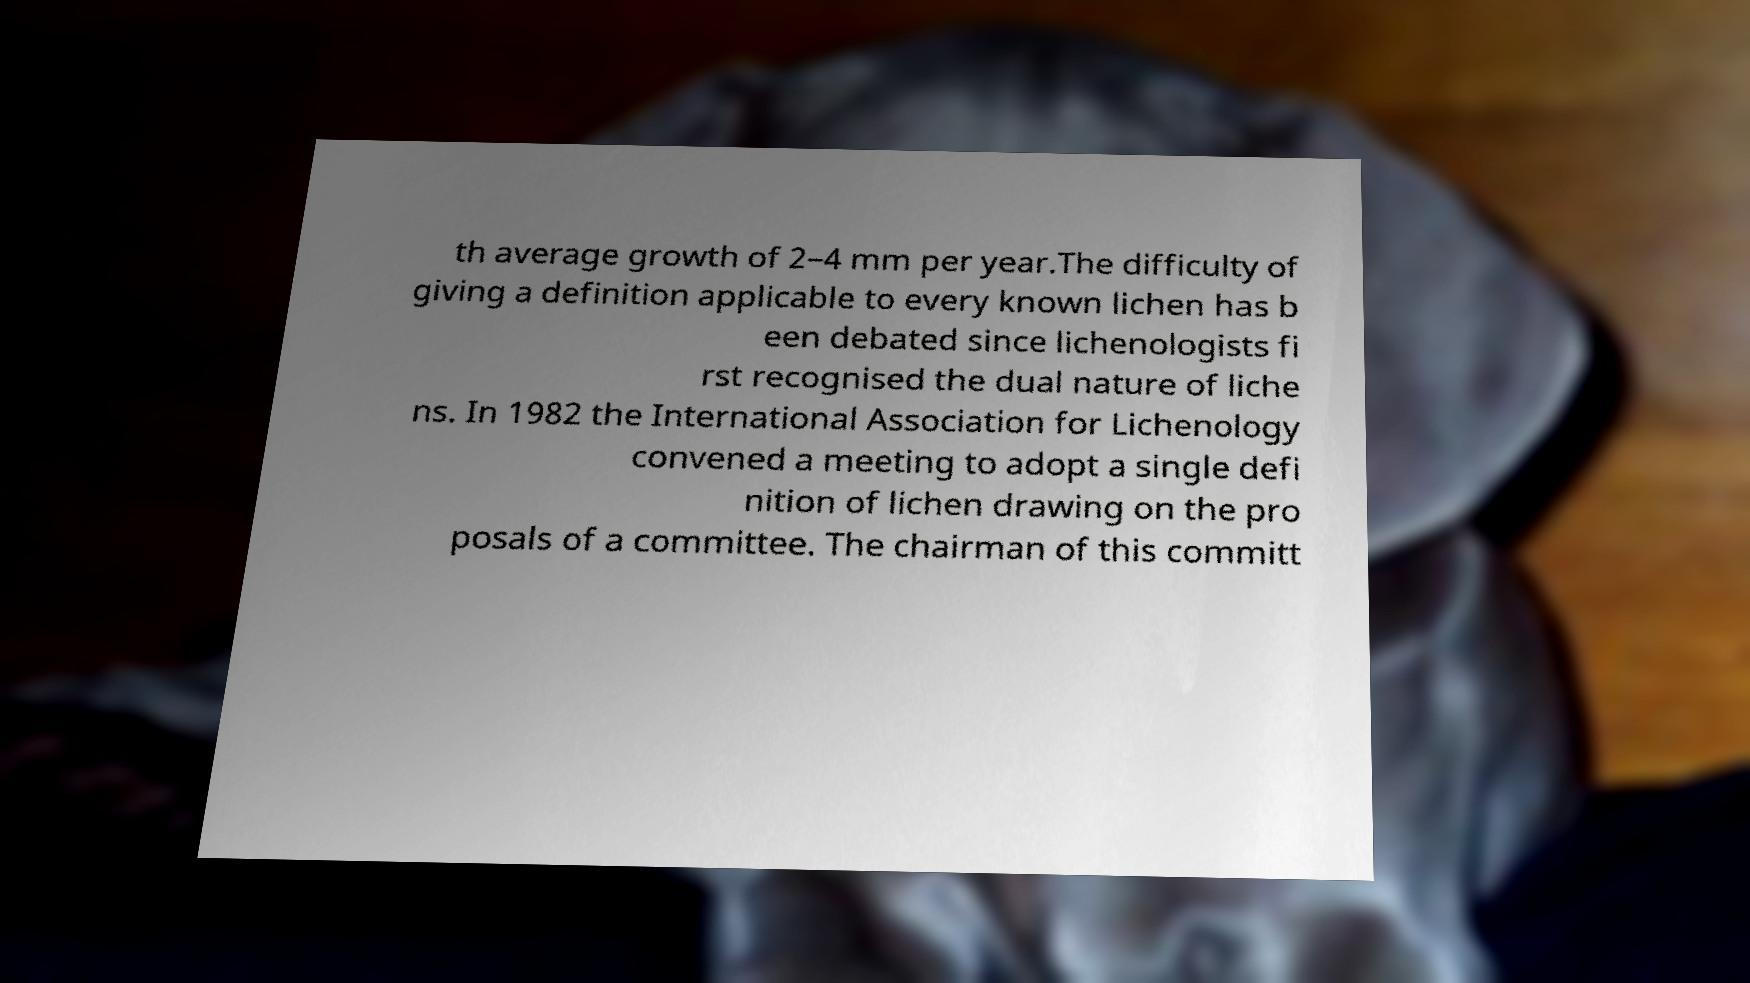There's text embedded in this image that I need extracted. Can you transcribe it verbatim? th average growth of 2–4 mm per year.The difficulty of giving a definition applicable to every known lichen has b een debated since lichenologists fi rst recognised the dual nature of liche ns. In 1982 the International Association for Lichenology convened a meeting to adopt a single defi nition of lichen drawing on the pro posals of a committee. The chairman of this committ 